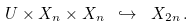Convert formula to latex. <formula><loc_0><loc_0><loc_500><loc_500>U \times X _ { n } \times X _ { n } \ \hookrightarrow \ X _ { 2 n } \, .</formula> 